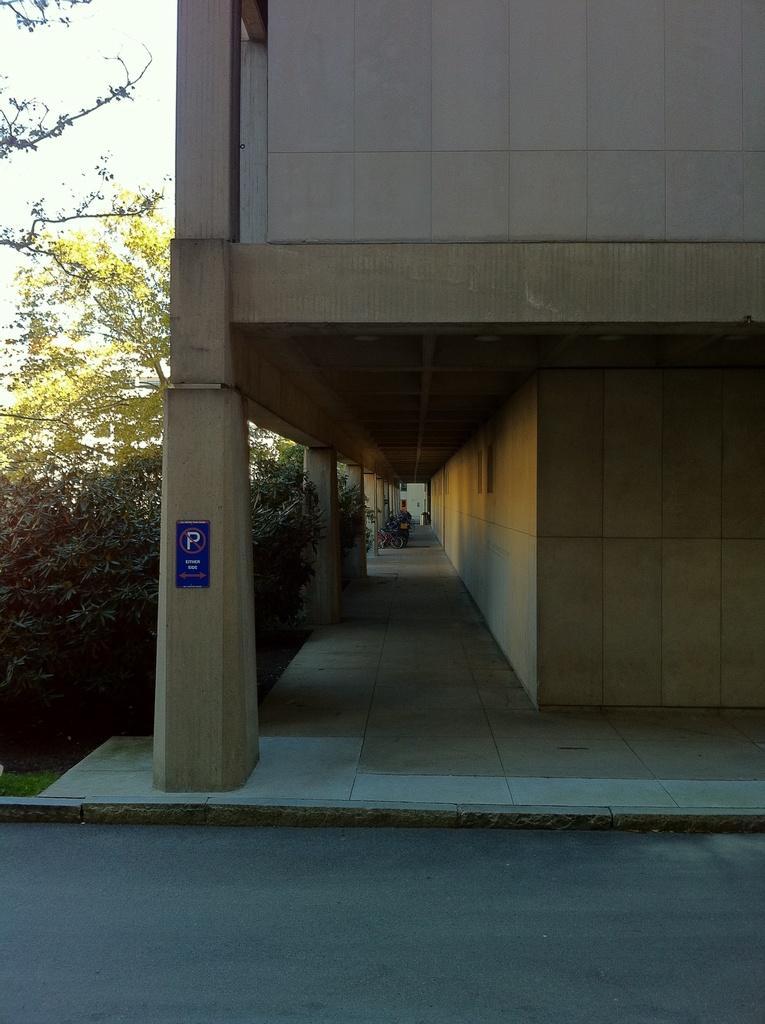Please provide a concise description of this image. In this picture we can see a building, on the left side there are trees, we can see pillars in the middle, it looks like a dustbin in the background, there is the sky at the left top of the picture, there is a board pasted on this pillar. 